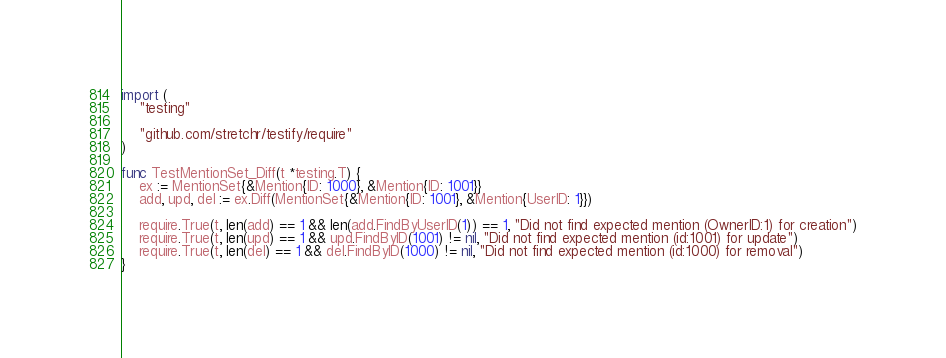Convert code to text. <code><loc_0><loc_0><loc_500><loc_500><_Go_>import (
	"testing"

	"github.com/stretchr/testify/require"
)

func TestMentionSet_Diff(t *testing.T) {
	ex := MentionSet{&Mention{ID: 1000}, &Mention{ID: 1001}}
	add, upd, del := ex.Diff(MentionSet{&Mention{ID: 1001}, &Mention{UserID: 1}})

	require.True(t, len(add) == 1 && len(add.FindByUserID(1)) == 1, "Did not find expected mention (OwnerID:1) for creation")
	require.True(t, len(upd) == 1 && upd.FindByID(1001) != nil, "Did not find expected mention (id:1001) for update")
	require.True(t, len(del) == 1 && del.FindByID(1000) != nil, "Did not find expected mention (id:1000) for removal")
}
</code> 